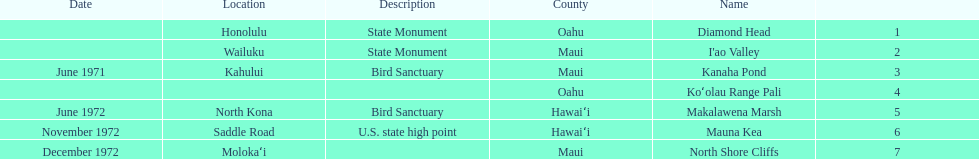How many locations are bird sanctuaries. 2. 